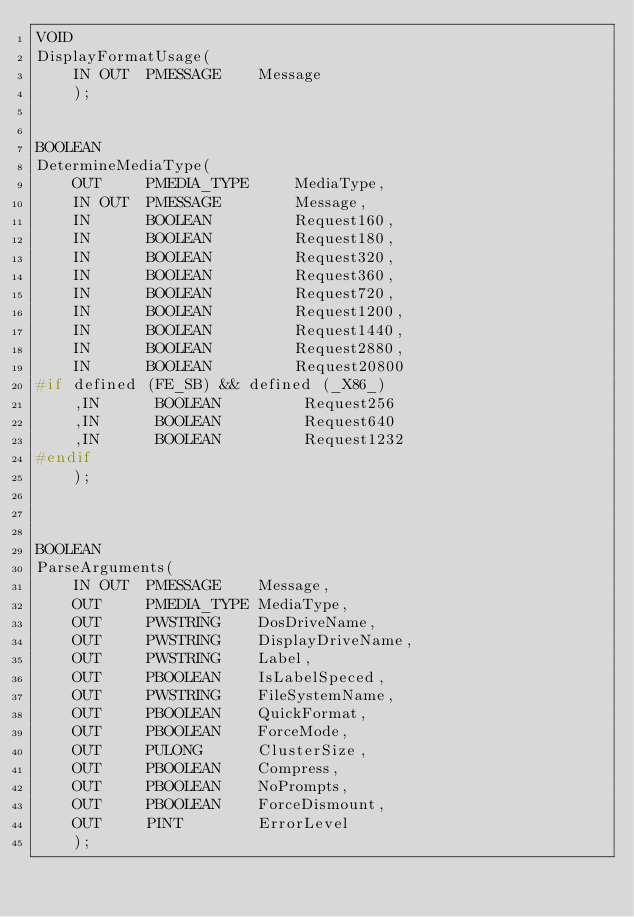<code> <loc_0><loc_0><loc_500><loc_500><_C++_>VOID
DisplayFormatUsage(
    IN OUT  PMESSAGE    Message
    );


BOOLEAN
DetermineMediaType(
    OUT     PMEDIA_TYPE     MediaType,
    IN OUT  PMESSAGE        Message,
    IN      BOOLEAN         Request160,
    IN      BOOLEAN         Request180,
    IN      BOOLEAN         Request320,
    IN      BOOLEAN         Request360,
    IN      BOOLEAN         Request720,
    IN      BOOLEAN         Request1200,
    IN      BOOLEAN         Request1440,
    IN      BOOLEAN         Request2880,
    IN      BOOLEAN         Request20800
#if defined (FE_SB) && defined (_X86_)
    ,IN      BOOLEAN         Request256
    ,IN      BOOLEAN         Request640
    ,IN      BOOLEAN         Request1232
#endif
    );



BOOLEAN
ParseArguments(
    IN OUT  PMESSAGE    Message,
    OUT     PMEDIA_TYPE MediaType,
    OUT     PWSTRING    DosDriveName,
    OUT     PWSTRING    DisplayDriveName,
    OUT     PWSTRING    Label,
    OUT     PBOOLEAN    IsLabelSpeced,
    OUT     PWSTRING    FileSystemName,
    OUT     PBOOLEAN    QuickFormat,
    OUT     PBOOLEAN    ForceMode,
    OUT     PULONG      ClusterSize,
    OUT     PBOOLEAN    Compress,
    OUT     PBOOLEAN    NoPrompts,
    OUT     PBOOLEAN    ForceDismount,
    OUT     PINT        ErrorLevel
    );
</code> 